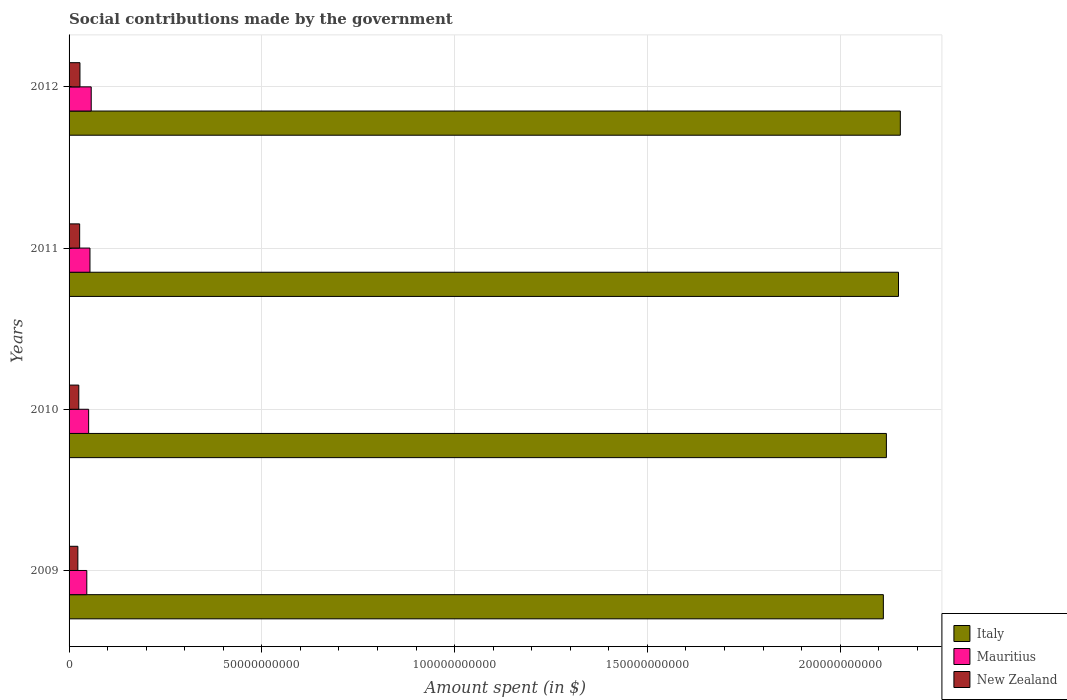How many different coloured bars are there?
Offer a terse response. 3. How many bars are there on the 3rd tick from the top?
Keep it short and to the point. 3. What is the label of the 1st group of bars from the top?
Your response must be concise. 2012. What is the amount spent on social contributions in New Zealand in 2010?
Your response must be concise. 2.52e+09. Across all years, what is the maximum amount spent on social contributions in New Zealand?
Offer a very short reply. 2.82e+09. Across all years, what is the minimum amount spent on social contributions in New Zealand?
Offer a terse response. 2.28e+09. In which year was the amount spent on social contributions in Mauritius maximum?
Your response must be concise. 2012. What is the total amount spent on social contributions in Mauritius in the graph?
Keep it short and to the point. 2.08e+1. What is the difference between the amount spent on social contributions in Italy in 2009 and that in 2012?
Your response must be concise. -4.40e+09. What is the difference between the amount spent on social contributions in Italy in 2009 and the amount spent on social contributions in New Zealand in 2011?
Make the answer very short. 2.08e+11. What is the average amount spent on social contributions in New Zealand per year?
Give a very brief answer. 2.59e+09. In the year 2009, what is the difference between the amount spent on social contributions in New Zealand and amount spent on social contributions in Italy?
Ensure brevity in your answer.  -2.09e+11. In how many years, is the amount spent on social contributions in New Zealand greater than 60000000000 $?
Give a very brief answer. 0. What is the ratio of the amount spent on social contributions in New Zealand in 2010 to that in 2011?
Your answer should be very brief. 0.92. Is the amount spent on social contributions in Mauritius in 2009 less than that in 2010?
Ensure brevity in your answer.  Yes. What is the difference between the highest and the second highest amount spent on social contributions in Italy?
Your answer should be very brief. 4.74e+08. What is the difference between the highest and the lowest amount spent on social contributions in New Zealand?
Provide a succinct answer. 5.42e+08. In how many years, is the amount spent on social contributions in New Zealand greater than the average amount spent on social contributions in New Zealand taken over all years?
Offer a very short reply. 2. Is the sum of the amount spent on social contributions in Mauritius in 2011 and 2012 greater than the maximum amount spent on social contributions in Italy across all years?
Provide a succinct answer. No. What does the 1st bar from the top in 2012 represents?
Your answer should be very brief. New Zealand. What does the 2nd bar from the bottom in 2011 represents?
Provide a succinct answer. Mauritius. Are all the bars in the graph horizontal?
Keep it short and to the point. Yes. How many years are there in the graph?
Your answer should be very brief. 4. Does the graph contain any zero values?
Ensure brevity in your answer.  No. What is the title of the graph?
Give a very brief answer. Social contributions made by the government. Does "Low income" appear as one of the legend labels in the graph?
Keep it short and to the point. No. What is the label or title of the X-axis?
Your answer should be compact. Amount spent (in $). What is the Amount spent (in $) of Italy in 2009?
Your answer should be very brief. 2.11e+11. What is the Amount spent (in $) in Mauritius in 2009?
Your answer should be compact. 4.60e+09. What is the Amount spent (in $) of New Zealand in 2009?
Keep it short and to the point. 2.28e+09. What is the Amount spent (in $) in Italy in 2010?
Offer a very short reply. 2.12e+11. What is the Amount spent (in $) of Mauritius in 2010?
Keep it short and to the point. 5.08e+09. What is the Amount spent (in $) of New Zealand in 2010?
Offer a very short reply. 2.52e+09. What is the Amount spent (in $) of Italy in 2011?
Provide a short and direct response. 2.15e+11. What is the Amount spent (in $) of Mauritius in 2011?
Provide a short and direct response. 5.42e+09. What is the Amount spent (in $) in New Zealand in 2011?
Give a very brief answer. 2.75e+09. What is the Amount spent (in $) in Italy in 2012?
Offer a terse response. 2.16e+11. What is the Amount spent (in $) in Mauritius in 2012?
Keep it short and to the point. 5.74e+09. What is the Amount spent (in $) of New Zealand in 2012?
Keep it short and to the point. 2.82e+09. Across all years, what is the maximum Amount spent (in $) in Italy?
Keep it short and to the point. 2.16e+11. Across all years, what is the maximum Amount spent (in $) in Mauritius?
Ensure brevity in your answer.  5.74e+09. Across all years, what is the maximum Amount spent (in $) of New Zealand?
Provide a short and direct response. 2.82e+09. Across all years, what is the minimum Amount spent (in $) of Italy?
Ensure brevity in your answer.  2.11e+11. Across all years, what is the minimum Amount spent (in $) in Mauritius?
Your answer should be compact. 4.60e+09. Across all years, what is the minimum Amount spent (in $) in New Zealand?
Your answer should be compact. 2.28e+09. What is the total Amount spent (in $) in Italy in the graph?
Make the answer very short. 8.54e+11. What is the total Amount spent (in $) in Mauritius in the graph?
Your response must be concise. 2.08e+1. What is the total Amount spent (in $) of New Zealand in the graph?
Give a very brief answer. 1.04e+1. What is the difference between the Amount spent (in $) in Italy in 2009 and that in 2010?
Your response must be concise. -7.86e+08. What is the difference between the Amount spent (in $) in Mauritius in 2009 and that in 2010?
Offer a terse response. -4.80e+08. What is the difference between the Amount spent (in $) in New Zealand in 2009 and that in 2010?
Provide a short and direct response. -2.44e+08. What is the difference between the Amount spent (in $) in Italy in 2009 and that in 2011?
Ensure brevity in your answer.  -3.93e+09. What is the difference between the Amount spent (in $) of Mauritius in 2009 and that in 2011?
Offer a very short reply. -8.24e+08. What is the difference between the Amount spent (in $) in New Zealand in 2009 and that in 2011?
Keep it short and to the point. -4.67e+08. What is the difference between the Amount spent (in $) in Italy in 2009 and that in 2012?
Your answer should be very brief. -4.40e+09. What is the difference between the Amount spent (in $) of Mauritius in 2009 and that in 2012?
Your answer should be very brief. -1.15e+09. What is the difference between the Amount spent (in $) in New Zealand in 2009 and that in 2012?
Ensure brevity in your answer.  -5.42e+08. What is the difference between the Amount spent (in $) in Italy in 2010 and that in 2011?
Keep it short and to the point. -3.14e+09. What is the difference between the Amount spent (in $) in Mauritius in 2010 and that in 2011?
Ensure brevity in your answer.  -3.45e+08. What is the difference between the Amount spent (in $) in New Zealand in 2010 and that in 2011?
Your answer should be compact. -2.23e+08. What is the difference between the Amount spent (in $) in Italy in 2010 and that in 2012?
Provide a succinct answer. -3.62e+09. What is the difference between the Amount spent (in $) in Mauritius in 2010 and that in 2012?
Your answer should be compact. -6.65e+08. What is the difference between the Amount spent (in $) in New Zealand in 2010 and that in 2012?
Your answer should be compact. -2.98e+08. What is the difference between the Amount spent (in $) in Italy in 2011 and that in 2012?
Your answer should be very brief. -4.74e+08. What is the difference between the Amount spent (in $) of Mauritius in 2011 and that in 2012?
Make the answer very short. -3.21e+08. What is the difference between the Amount spent (in $) of New Zealand in 2011 and that in 2012?
Give a very brief answer. -7.55e+07. What is the difference between the Amount spent (in $) of Italy in 2009 and the Amount spent (in $) of Mauritius in 2010?
Keep it short and to the point. 2.06e+11. What is the difference between the Amount spent (in $) of Italy in 2009 and the Amount spent (in $) of New Zealand in 2010?
Keep it short and to the point. 2.09e+11. What is the difference between the Amount spent (in $) of Mauritius in 2009 and the Amount spent (in $) of New Zealand in 2010?
Keep it short and to the point. 2.08e+09. What is the difference between the Amount spent (in $) of Italy in 2009 and the Amount spent (in $) of Mauritius in 2011?
Your answer should be compact. 2.06e+11. What is the difference between the Amount spent (in $) of Italy in 2009 and the Amount spent (in $) of New Zealand in 2011?
Make the answer very short. 2.08e+11. What is the difference between the Amount spent (in $) in Mauritius in 2009 and the Amount spent (in $) in New Zealand in 2011?
Make the answer very short. 1.85e+09. What is the difference between the Amount spent (in $) in Italy in 2009 and the Amount spent (in $) in Mauritius in 2012?
Ensure brevity in your answer.  2.05e+11. What is the difference between the Amount spent (in $) of Italy in 2009 and the Amount spent (in $) of New Zealand in 2012?
Make the answer very short. 2.08e+11. What is the difference between the Amount spent (in $) in Mauritius in 2009 and the Amount spent (in $) in New Zealand in 2012?
Keep it short and to the point. 1.78e+09. What is the difference between the Amount spent (in $) in Italy in 2010 and the Amount spent (in $) in Mauritius in 2011?
Offer a terse response. 2.07e+11. What is the difference between the Amount spent (in $) of Italy in 2010 and the Amount spent (in $) of New Zealand in 2011?
Your response must be concise. 2.09e+11. What is the difference between the Amount spent (in $) of Mauritius in 2010 and the Amount spent (in $) of New Zealand in 2011?
Your response must be concise. 2.33e+09. What is the difference between the Amount spent (in $) of Italy in 2010 and the Amount spent (in $) of Mauritius in 2012?
Provide a succinct answer. 2.06e+11. What is the difference between the Amount spent (in $) in Italy in 2010 and the Amount spent (in $) in New Zealand in 2012?
Keep it short and to the point. 2.09e+11. What is the difference between the Amount spent (in $) of Mauritius in 2010 and the Amount spent (in $) of New Zealand in 2012?
Your answer should be very brief. 2.26e+09. What is the difference between the Amount spent (in $) in Italy in 2011 and the Amount spent (in $) in Mauritius in 2012?
Your response must be concise. 2.09e+11. What is the difference between the Amount spent (in $) in Italy in 2011 and the Amount spent (in $) in New Zealand in 2012?
Provide a short and direct response. 2.12e+11. What is the difference between the Amount spent (in $) of Mauritius in 2011 and the Amount spent (in $) of New Zealand in 2012?
Keep it short and to the point. 2.60e+09. What is the average Amount spent (in $) in Italy per year?
Offer a very short reply. 2.13e+11. What is the average Amount spent (in $) in Mauritius per year?
Ensure brevity in your answer.  5.21e+09. What is the average Amount spent (in $) in New Zealand per year?
Ensure brevity in your answer.  2.59e+09. In the year 2009, what is the difference between the Amount spent (in $) in Italy and Amount spent (in $) in Mauritius?
Your answer should be very brief. 2.07e+11. In the year 2009, what is the difference between the Amount spent (in $) of Italy and Amount spent (in $) of New Zealand?
Make the answer very short. 2.09e+11. In the year 2009, what is the difference between the Amount spent (in $) in Mauritius and Amount spent (in $) in New Zealand?
Your response must be concise. 2.32e+09. In the year 2010, what is the difference between the Amount spent (in $) in Italy and Amount spent (in $) in Mauritius?
Your response must be concise. 2.07e+11. In the year 2010, what is the difference between the Amount spent (in $) of Italy and Amount spent (in $) of New Zealand?
Give a very brief answer. 2.09e+11. In the year 2010, what is the difference between the Amount spent (in $) in Mauritius and Amount spent (in $) in New Zealand?
Your answer should be very brief. 2.56e+09. In the year 2011, what is the difference between the Amount spent (in $) of Italy and Amount spent (in $) of Mauritius?
Offer a terse response. 2.10e+11. In the year 2011, what is the difference between the Amount spent (in $) in Italy and Amount spent (in $) in New Zealand?
Give a very brief answer. 2.12e+11. In the year 2011, what is the difference between the Amount spent (in $) in Mauritius and Amount spent (in $) in New Zealand?
Give a very brief answer. 2.68e+09. In the year 2012, what is the difference between the Amount spent (in $) of Italy and Amount spent (in $) of Mauritius?
Provide a short and direct response. 2.10e+11. In the year 2012, what is the difference between the Amount spent (in $) of Italy and Amount spent (in $) of New Zealand?
Provide a succinct answer. 2.13e+11. In the year 2012, what is the difference between the Amount spent (in $) in Mauritius and Amount spent (in $) in New Zealand?
Provide a short and direct response. 2.92e+09. What is the ratio of the Amount spent (in $) in Mauritius in 2009 to that in 2010?
Your answer should be compact. 0.91. What is the ratio of the Amount spent (in $) in New Zealand in 2009 to that in 2010?
Your response must be concise. 0.9. What is the ratio of the Amount spent (in $) in Italy in 2009 to that in 2011?
Provide a succinct answer. 0.98. What is the ratio of the Amount spent (in $) of Mauritius in 2009 to that in 2011?
Offer a terse response. 0.85. What is the ratio of the Amount spent (in $) in New Zealand in 2009 to that in 2011?
Offer a very short reply. 0.83. What is the ratio of the Amount spent (in $) in Italy in 2009 to that in 2012?
Make the answer very short. 0.98. What is the ratio of the Amount spent (in $) in Mauritius in 2009 to that in 2012?
Your response must be concise. 0.8. What is the ratio of the Amount spent (in $) of New Zealand in 2009 to that in 2012?
Make the answer very short. 0.81. What is the ratio of the Amount spent (in $) in Italy in 2010 to that in 2011?
Your answer should be compact. 0.99. What is the ratio of the Amount spent (in $) in Mauritius in 2010 to that in 2011?
Provide a short and direct response. 0.94. What is the ratio of the Amount spent (in $) in New Zealand in 2010 to that in 2011?
Make the answer very short. 0.92. What is the ratio of the Amount spent (in $) of Italy in 2010 to that in 2012?
Provide a short and direct response. 0.98. What is the ratio of the Amount spent (in $) in Mauritius in 2010 to that in 2012?
Provide a short and direct response. 0.88. What is the ratio of the Amount spent (in $) in New Zealand in 2010 to that in 2012?
Offer a terse response. 0.89. What is the ratio of the Amount spent (in $) of Mauritius in 2011 to that in 2012?
Offer a very short reply. 0.94. What is the ratio of the Amount spent (in $) in New Zealand in 2011 to that in 2012?
Your answer should be very brief. 0.97. What is the difference between the highest and the second highest Amount spent (in $) of Italy?
Ensure brevity in your answer.  4.74e+08. What is the difference between the highest and the second highest Amount spent (in $) of Mauritius?
Keep it short and to the point. 3.21e+08. What is the difference between the highest and the second highest Amount spent (in $) of New Zealand?
Give a very brief answer. 7.55e+07. What is the difference between the highest and the lowest Amount spent (in $) of Italy?
Ensure brevity in your answer.  4.40e+09. What is the difference between the highest and the lowest Amount spent (in $) in Mauritius?
Make the answer very short. 1.15e+09. What is the difference between the highest and the lowest Amount spent (in $) in New Zealand?
Keep it short and to the point. 5.42e+08. 